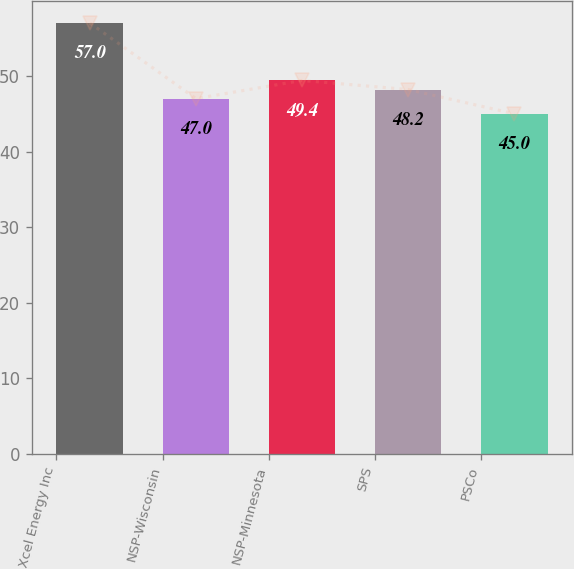Convert chart to OTSL. <chart><loc_0><loc_0><loc_500><loc_500><bar_chart><fcel>Xcel Energy Inc<fcel>NSP-Wisconsin<fcel>NSP-Minnesota<fcel>SPS<fcel>PSCo<nl><fcel>57<fcel>47<fcel>49.4<fcel>48.2<fcel>45<nl></chart> 